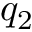<formula> <loc_0><loc_0><loc_500><loc_500>q _ { 2 }</formula> 